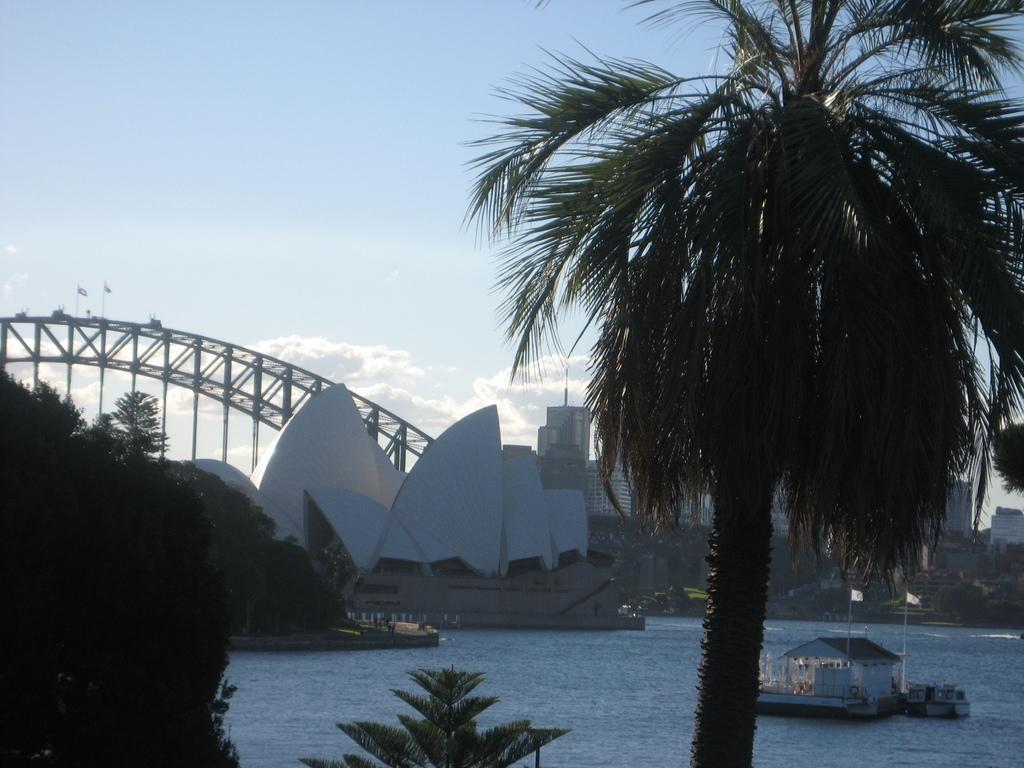Could you give a brief overview of what you see in this image? In this image, we can see some trees. There is a river at the bottom of the image. There is an architecture in the middle of the image. There is a shelter house on the bottom right of the image. There is a sky at the top of the image. 